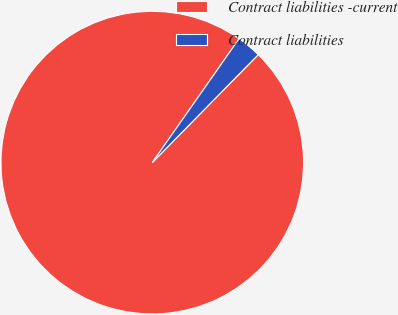Convert chart to OTSL. <chart><loc_0><loc_0><loc_500><loc_500><pie_chart><fcel>Contract liabilities -current<fcel>Contract liabilities<nl><fcel>97.38%<fcel>2.62%<nl></chart> 